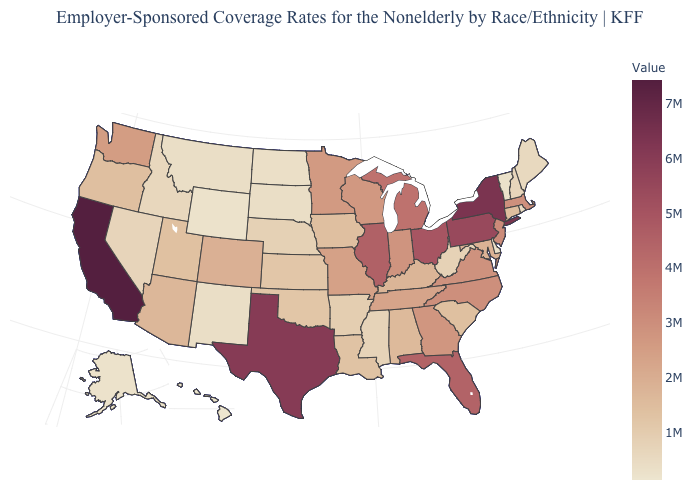Is the legend a continuous bar?
Answer briefly. Yes. Which states have the lowest value in the USA?
Write a very short answer. Hawaii. Which states have the lowest value in the South?
Keep it brief. Delaware. Does Hawaii have the lowest value in the USA?
Answer briefly. Yes. Does the map have missing data?
Quick response, please. No. Does Maryland have the lowest value in the USA?
Quick response, please. No. Which states hav the highest value in the West?
Give a very brief answer. California. Among the states that border Indiana , does Illinois have the lowest value?
Write a very short answer. No. Which states hav the highest value in the Northeast?
Answer briefly. New York. 